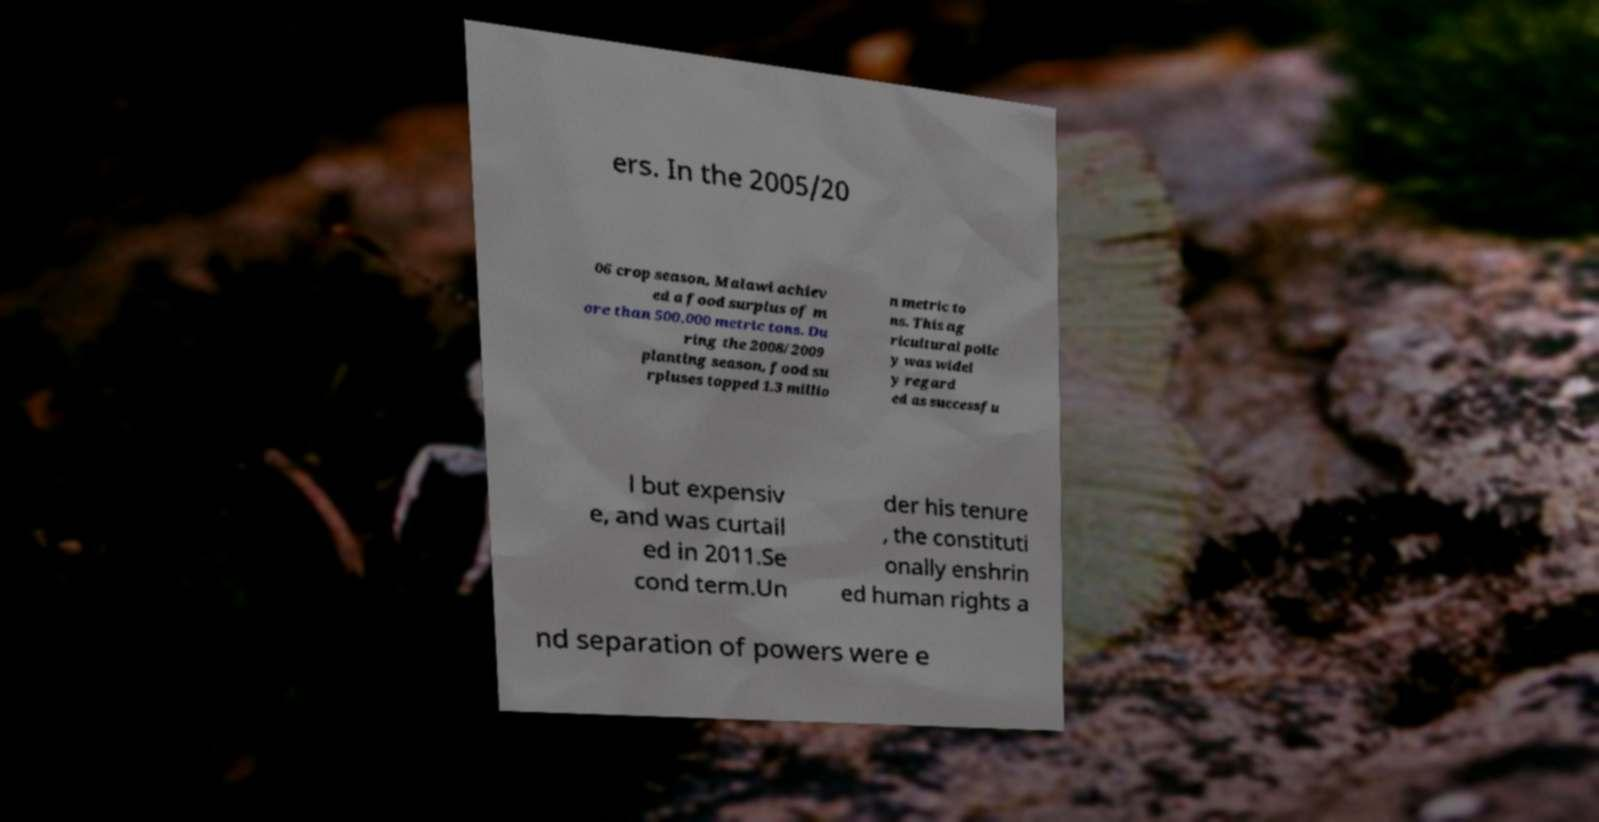Can you accurately transcribe the text from the provided image for me? ers. In the 2005/20 06 crop season, Malawi achiev ed a food surplus of m ore than 500,000 metric tons. Du ring the 2008/2009 planting season, food su rpluses topped 1.3 millio n metric to ns. This ag ricultural polic y was widel y regard ed as successfu l but expensiv e, and was curtail ed in 2011.Se cond term.Un der his tenure , the constituti onally enshrin ed human rights a nd separation of powers were e 